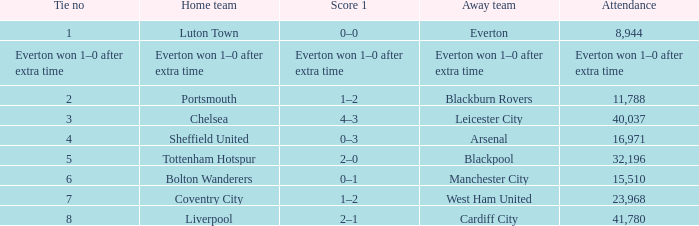Would you be able to parse every entry in this table? {'header': ['Tie no', 'Home team', 'Score 1', 'Away team', 'Attendance'], 'rows': [['1', 'Luton Town', '0–0', 'Everton', '8,944'], ['Everton won 1–0 after extra time', 'Everton won 1–0 after extra time', 'Everton won 1–0 after extra time', 'Everton won 1–0 after extra time', 'Everton won 1–0 after extra time'], ['2', 'Portsmouth', '1–2', 'Blackburn Rovers', '11,788'], ['3', 'Chelsea', '4–3', 'Leicester City', '40,037'], ['4', 'Sheffield United', '0–3', 'Arsenal', '16,971'], ['5', 'Tottenham Hotspur', '2–0', 'Blackpool', '32,196'], ['6', 'Bolton Wanderers', '0–1', 'Manchester City', '15,510'], ['7', 'Coventry City', '1–2', 'West Ham United', '23,968'], ['8', 'Liverpool', '2–1', 'Cardiff City', '41,780']]} What home team had an attendance record of 16,971? Sheffield United. 